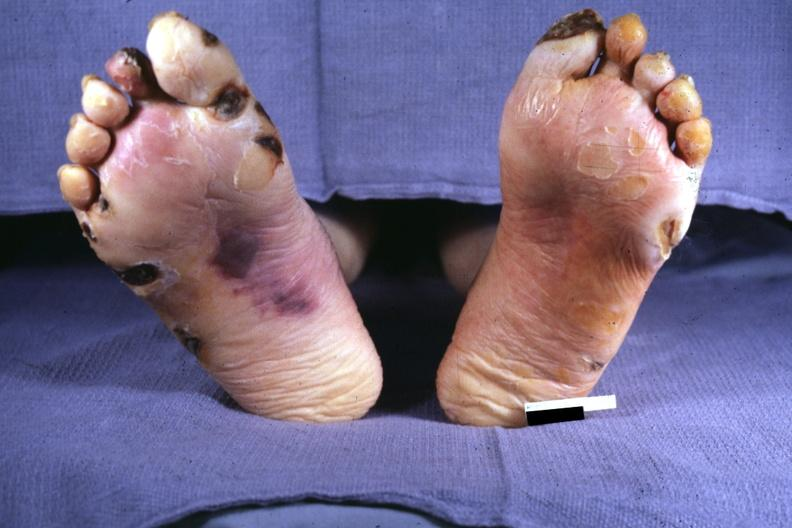what is present?
Answer the question using a single word or phrase. Feet 